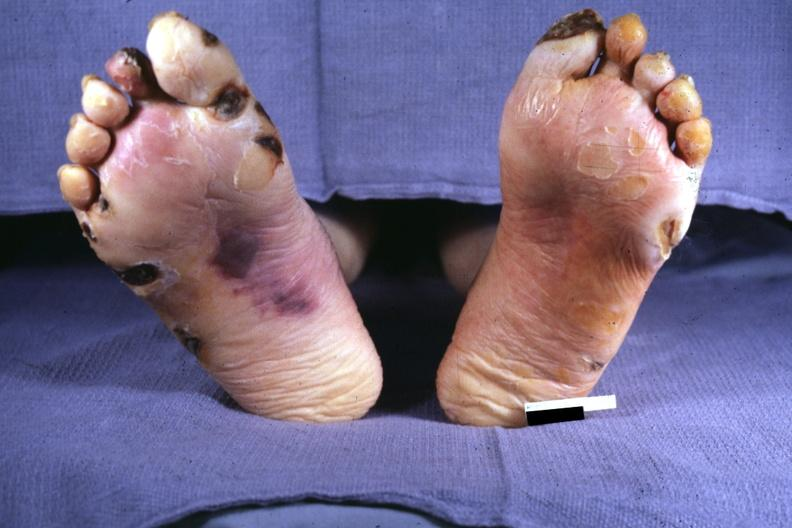what is present?
Answer the question using a single word or phrase. Feet 